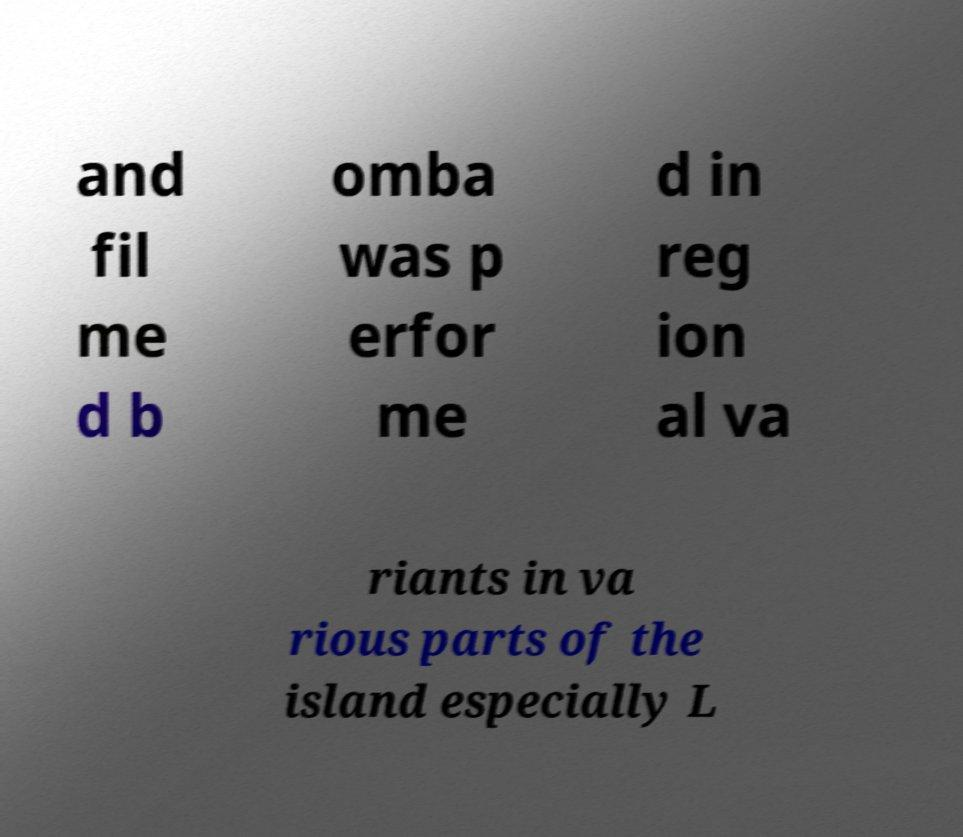What messages or text are displayed in this image? I need them in a readable, typed format. and fil me d b omba was p erfor me d in reg ion al va riants in va rious parts of the island especially L 